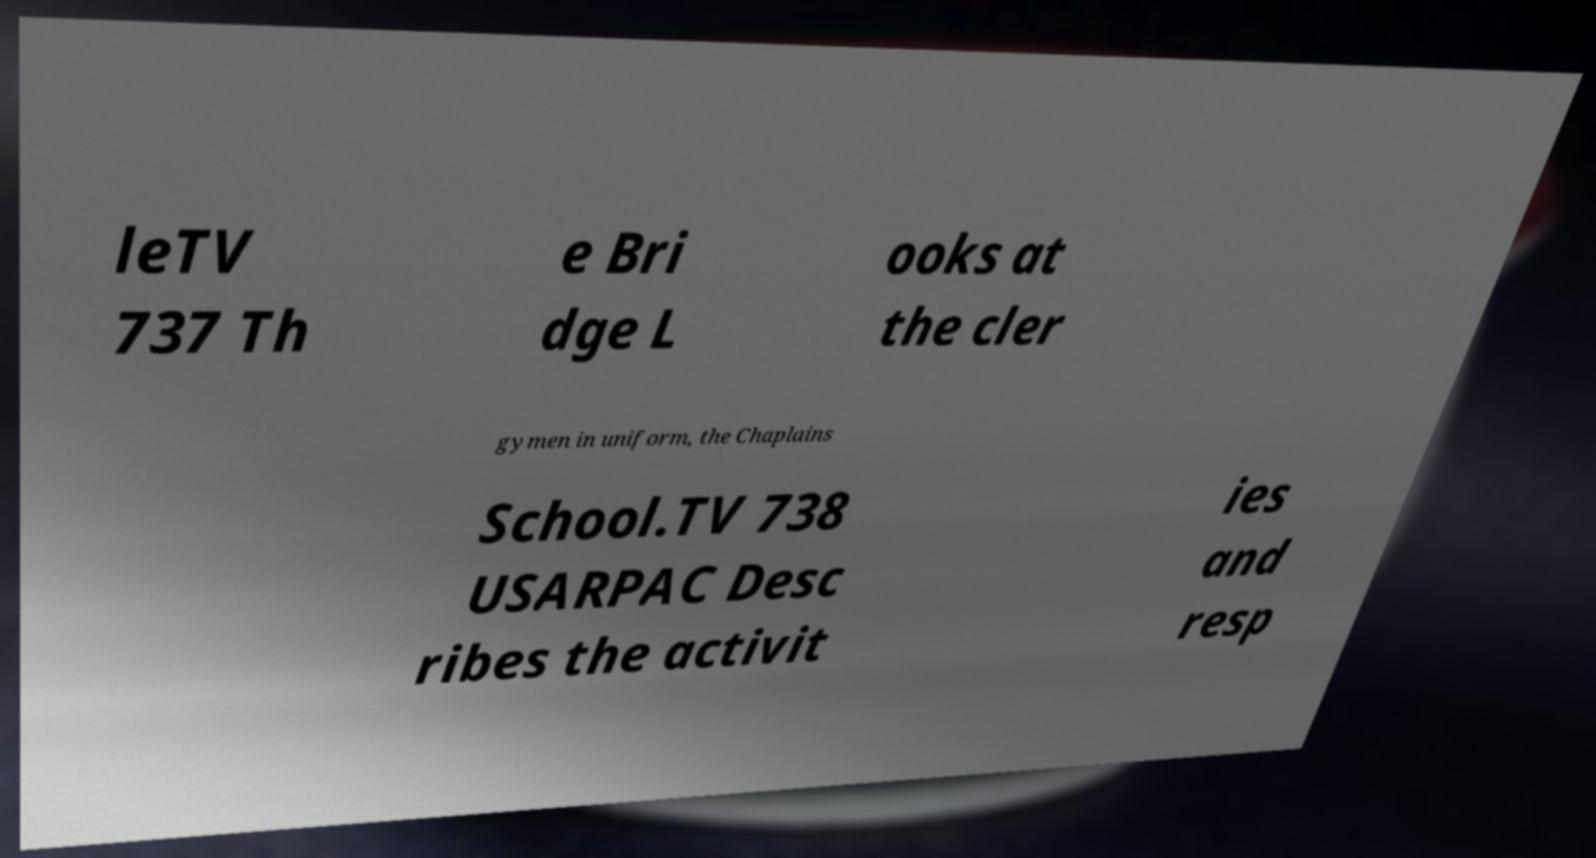Could you extract and type out the text from this image? leTV 737 Th e Bri dge L ooks at the cler gymen in uniform, the Chaplains School.TV 738 USARPAC Desc ribes the activit ies and resp 